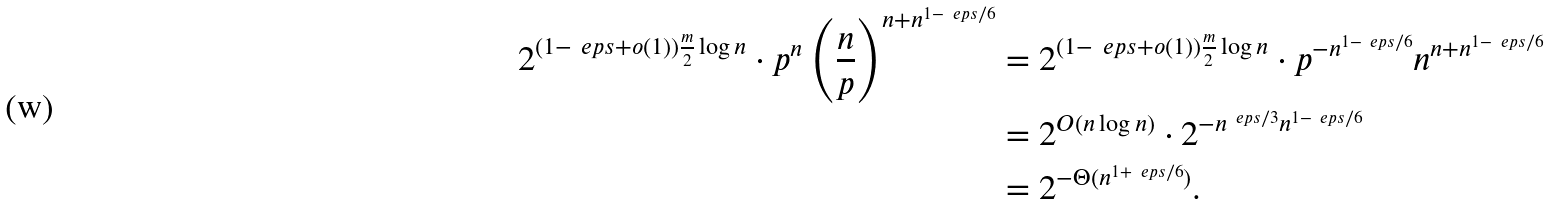Convert formula to latex. <formula><loc_0><loc_0><loc_500><loc_500>2 ^ { ( 1 - \ e p s + o ( 1 ) ) \frac { m } { 2 } \log n } \cdot p ^ { n } \left ( \frac { n } { p } \right ) ^ { n + n ^ { 1 - \ e p s / 6 } } & = 2 ^ { ( 1 - \ e p s + o ( 1 ) ) \frac { m } { 2 } \log n } \cdot p ^ { - n ^ { 1 - \ e p s / 6 } } n ^ { n + n ^ { 1 - \ e p s / 6 } } \\ & = 2 ^ { O ( n \log n ) } \cdot 2 ^ { - n ^ { \ e p s / 3 } n ^ { 1 - \ e p s / 6 } } \\ & = 2 ^ { - \Theta ( n ^ { 1 + \ e p s / 6 } ) } .</formula> 